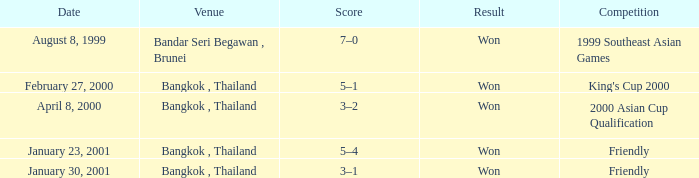What was the result of the game that was played on february 27, 2000? Won. 